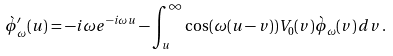<formula> <loc_0><loc_0><loc_500><loc_500>\grave { \phi } ^ { \prime } _ { \omega } ( u ) = - i \omega e ^ { - i \omega u } - \int _ { u } ^ { \infty } \cos ( \omega ( u - v ) ) V _ { 0 } ( v ) \grave { \phi } _ { \omega } ( v ) \, d v \, .</formula> 